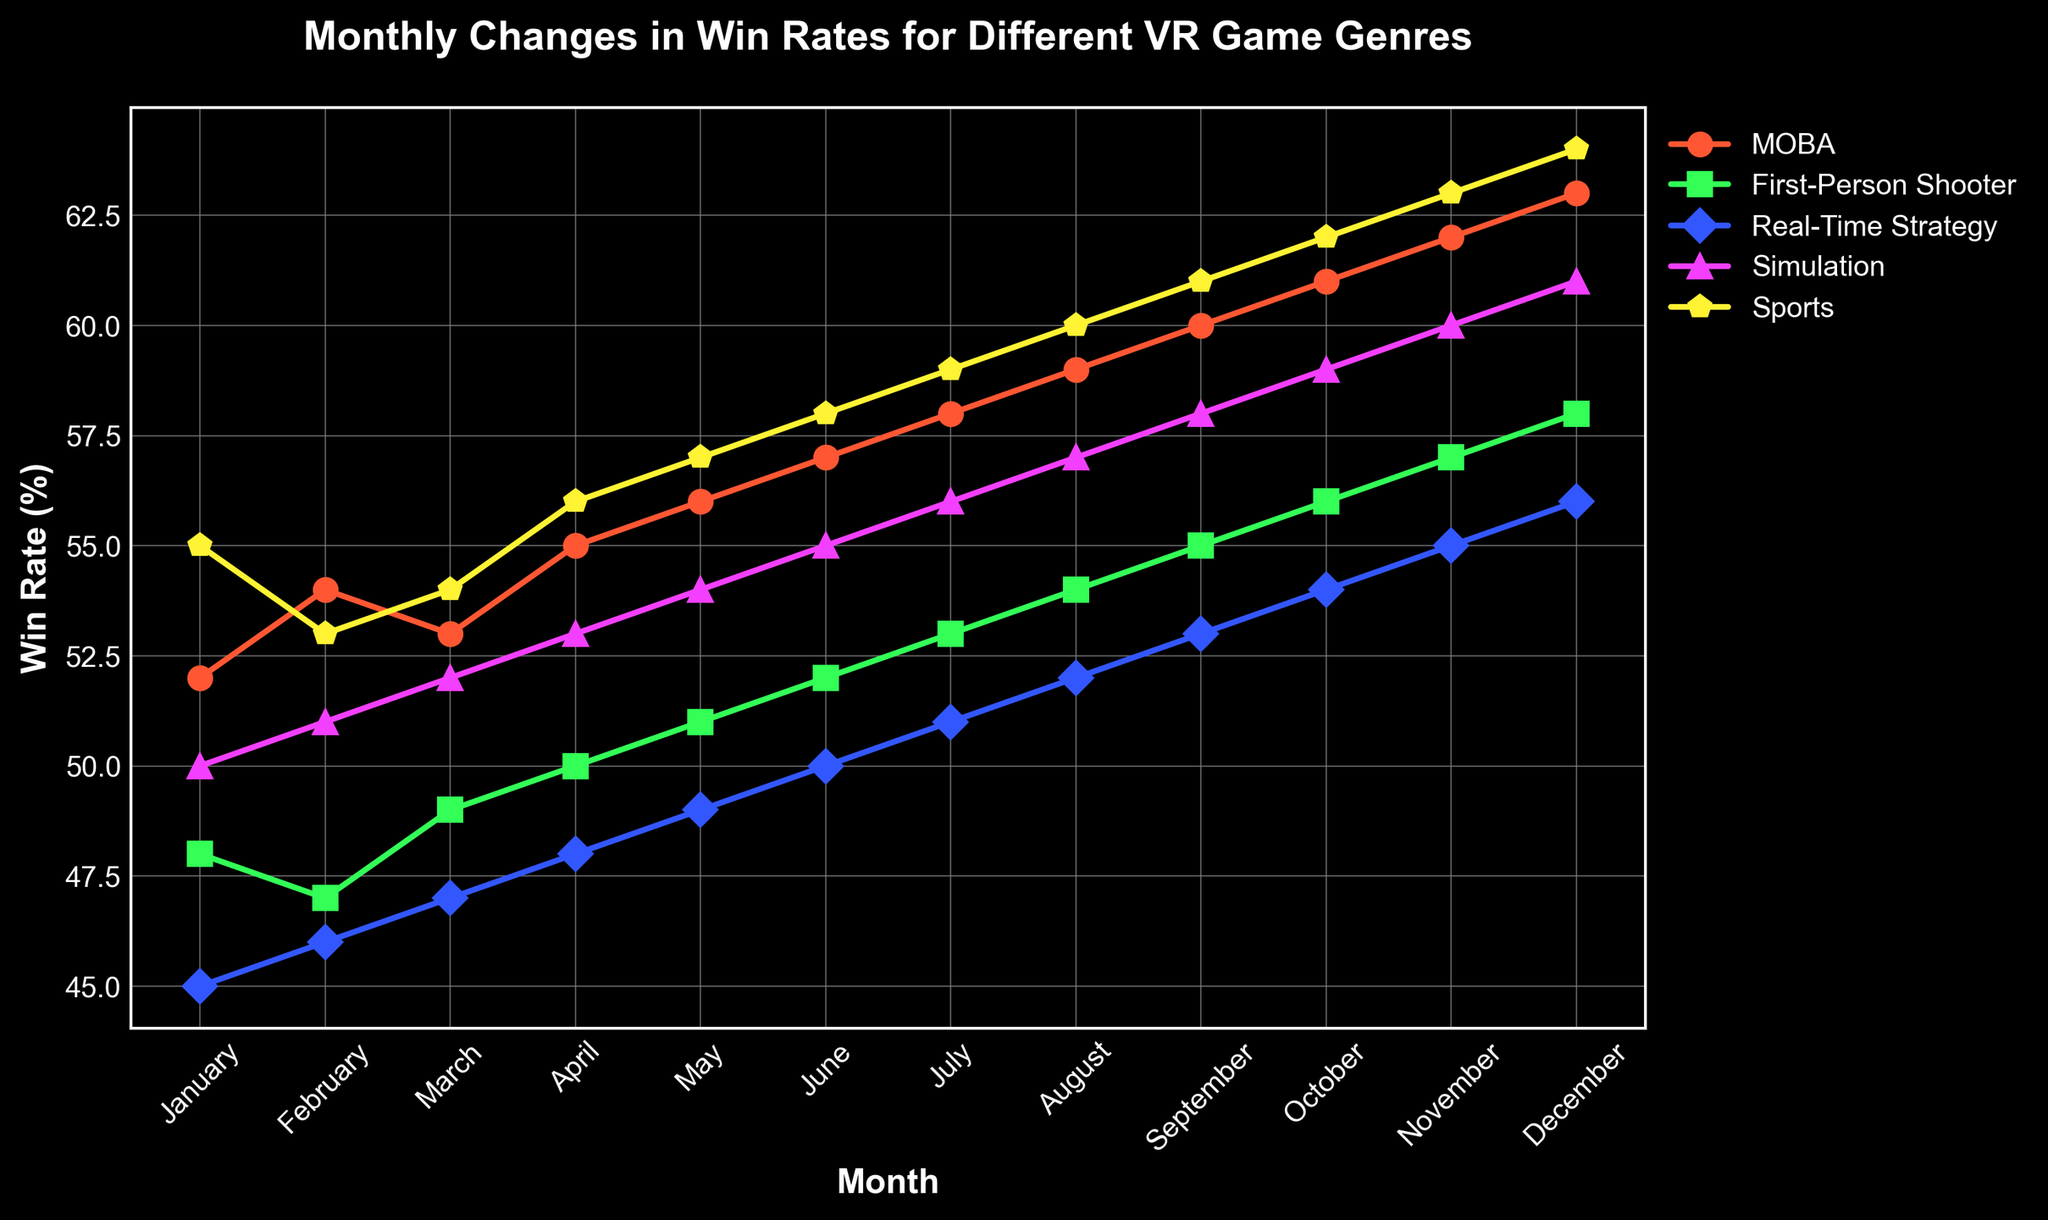What is the win rate trend for MOBA games from January to December? The win rate for MOBA games starts at 52% in January and gradually increases each month, reaching 63% by December. This shows a consistent positive trend over the year.
Answer: Gradual increase from 52% to 63% Which game genre had the highest win rate in September? In September, the highest win rate is 61%, which belongs to the Sports genre as observed from the plot.
Answer: Sports By how much did the win rate of First-Person Shooter games increase from February to November? The win rate in February for First-Person Shooter games is 47%, and in November it is 57%. The increase is calculated as 57% - 47% = 10%.
Answer: 10% During which month did the Real-Time Strategy genre see the highest win rate, and what was it? The highest win rate for Real-Time Strategy games is 56%, and it occurs in December.
Answer: December, 56% Which genre had the most consistent (least variable) win rate changes throughout the year? By visually inspecting the line plot, it can be seen that Simulation games have very small incremental increases each month, indicating the most consistent changes.
Answer: Simulation In August, how much higher was the win rate for MOBA games compared to Simulation games? In August, the win rate for MOBA is 59%, and for Simulation games it is 57%. The difference is 59% - 57% = 2%.
Answer: 2% What is the average win rate for Sports games over the entire year? Sum the monthly win rates for Sports games and divide by 12 (55 + 53 + 54 + 56 + 57 + 58 + 59 + 60 + 61 + 62 + 63 + 64) / 12 = 702 / 12 = 58.5%.
Answer: 58.5% Which two genres had the greatest difference in win rate in June, and what was the difference? In June, the highest win rate is for Sports (58%) and the lowest is for Real-Time Strategy (50%). The difference is 58% - 50% = 8%.
Answer: Sports and Real-Time Strategy, 8% In what month did the win rate for First-Person Shooter games surpass 50% for the first time? Observing the trend for First-Person Shooter games, the win rate first surpasses 50% in April (50%).
Answer: April 